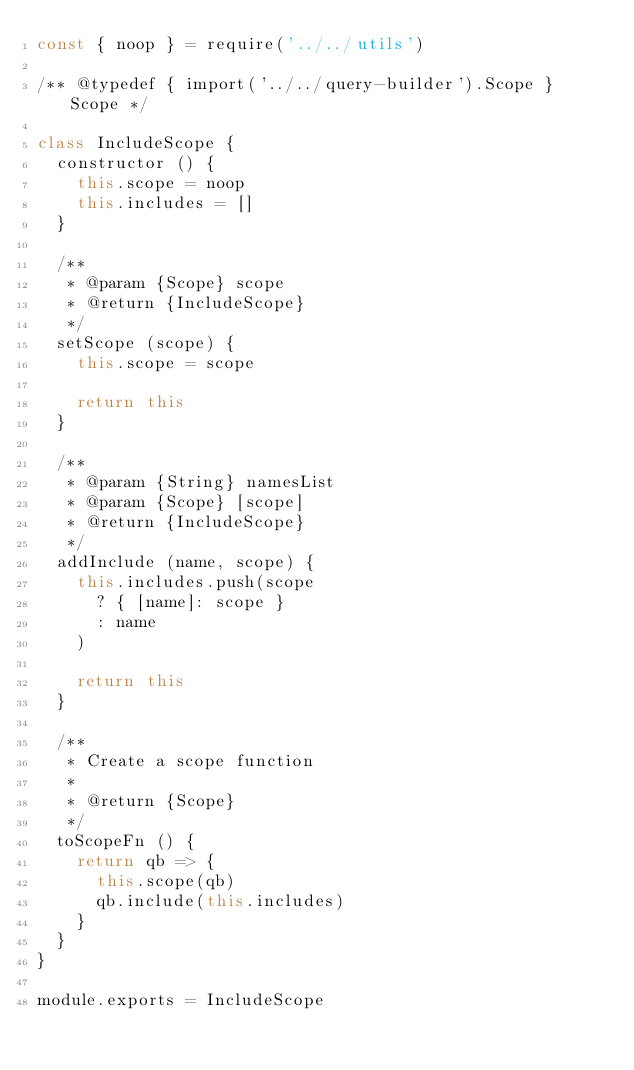Convert code to text. <code><loc_0><loc_0><loc_500><loc_500><_JavaScript_>const { noop } = require('../../utils')

/** @typedef { import('../../query-builder').Scope } Scope */

class IncludeScope {
  constructor () {
    this.scope = noop
    this.includes = []
  }

  /**
   * @param {Scope} scope
   * @return {IncludeScope}
   */
  setScope (scope) {
    this.scope = scope

    return this
  }

  /**
   * @param {String} namesList
   * @param {Scope} [scope]
   * @return {IncludeScope}
   */
  addInclude (name, scope) {
    this.includes.push(scope
      ? { [name]: scope }
      : name
    )

    return this
  }

  /**
   * Create a scope function
   *
   * @return {Scope}
   */
  toScopeFn () {
    return qb => {
      this.scope(qb)
      qb.include(this.includes)
    }
  }
}

module.exports = IncludeScope
</code> 